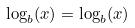Convert formula to latex. <formula><loc_0><loc_0><loc_500><loc_500>\log _ { b } ( x ) = \log _ { b } ( x )</formula> 